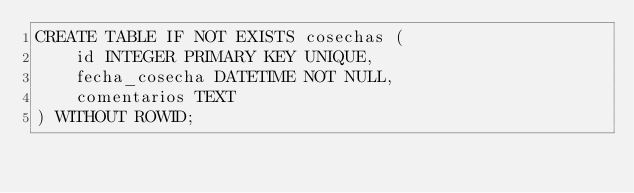<code> <loc_0><loc_0><loc_500><loc_500><_SQL_>CREATE TABLE IF NOT EXISTS cosechas (
    id INTEGER PRIMARY KEY UNIQUE,
	fecha_cosecha DATETIME NOT NULL,
    comentarios TEXT
) WITHOUT ROWID;

</code> 